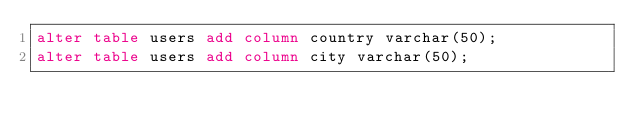Convert code to text. <code><loc_0><loc_0><loc_500><loc_500><_SQL_>alter table users add column country varchar(50);
alter table users add column city varchar(50);</code> 